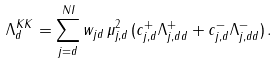<formula> <loc_0><loc_0><loc_500><loc_500>\Lambda _ { d } ^ { K K } = \sum _ { j = d } ^ { N I } w _ { j d } \, \mu _ { j , d } ^ { 2 } \, ( c _ { j , d } ^ { + } \Lambda _ { j , d d } ^ { + } + c _ { j , d } ^ { - } \Lambda _ { j , d d } ^ { - } ) \, .</formula> 